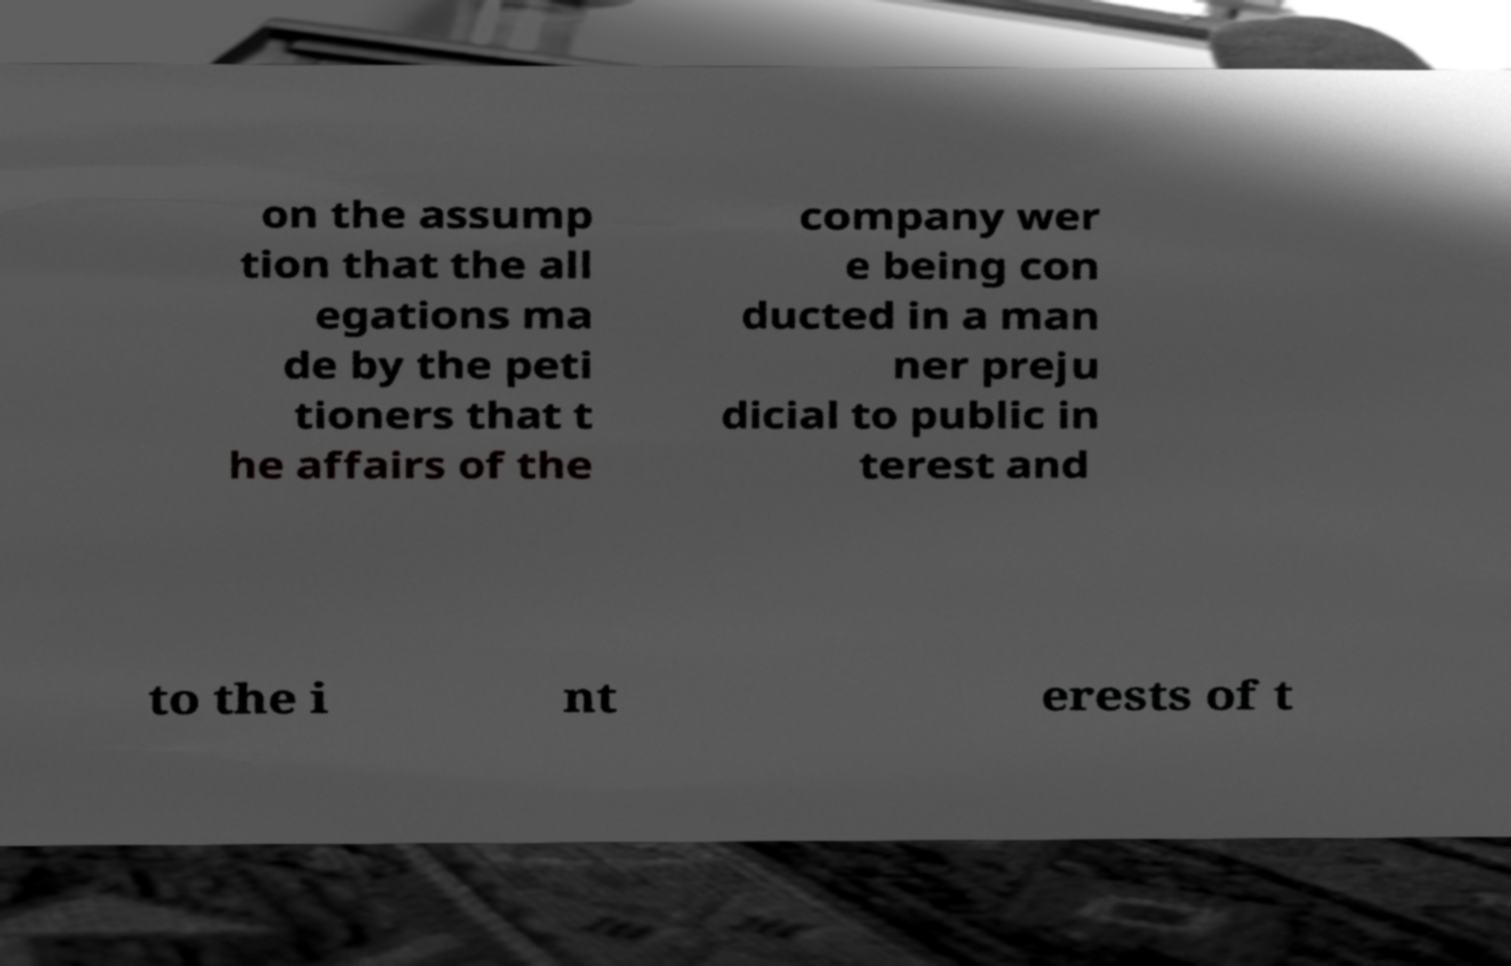Can you read and provide the text displayed in the image?This photo seems to have some interesting text. Can you extract and type it out for me? on the assump tion that the all egations ma de by the peti tioners that t he affairs of the company wer e being con ducted in a man ner preju dicial to public in terest and to the i nt erests of t 